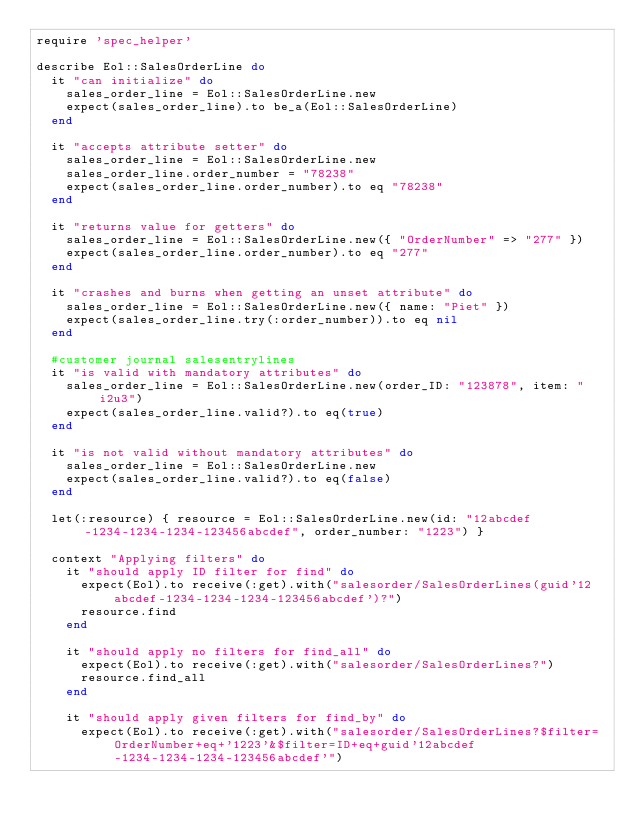<code> <loc_0><loc_0><loc_500><loc_500><_Ruby_>require 'spec_helper'

describe Eol::SalesOrderLine do
  it "can initialize" do
    sales_order_line = Eol::SalesOrderLine.new
    expect(sales_order_line).to be_a(Eol::SalesOrderLine)
  end

  it "accepts attribute setter" do
    sales_order_line = Eol::SalesOrderLine.new
    sales_order_line.order_number = "78238"
    expect(sales_order_line.order_number).to eq "78238"
  end

  it "returns value for getters" do
    sales_order_line = Eol::SalesOrderLine.new({ "OrderNumber" => "277" })
    expect(sales_order_line.order_number).to eq "277"
  end

  it "crashes and burns when getting an unset attribute" do
    sales_order_line = Eol::SalesOrderLine.new({ name: "Piet" })
    expect(sales_order_line.try(:order_number)).to eq nil
  end

  #customer journal salesentrylines
  it "is valid with mandatory attributes" do
    sales_order_line = Eol::SalesOrderLine.new(order_ID: "123878", item: "i2u3")
    expect(sales_order_line.valid?).to eq(true)
  end

  it "is not valid without mandatory attributes" do
    sales_order_line = Eol::SalesOrderLine.new
    expect(sales_order_line.valid?).to eq(false)
  end

  let(:resource) { resource = Eol::SalesOrderLine.new(id: "12abcdef-1234-1234-1234-123456abcdef", order_number: "1223") }

  context "Applying filters" do
    it "should apply ID filter for find" do
      expect(Eol).to receive(:get).with("salesorder/SalesOrderLines(guid'12abcdef-1234-1234-1234-123456abcdef')?")
      resource.find
    end

    it "should apply no filters for find_all" do
      expect(Eol).to receive(:get).with("salesorder/SalesOrderLines?")
      resource.find_all
    end

    it "should apply given filters for find_by" do
      expect(Eol).to receive(:get).with("salesorder/SalesOrderLines?$filter=OrderNumber+eq+'1223'&$filter=ID+eq+guid'12abcdef-1234-1234-1234-123456abcdef'")</code> 